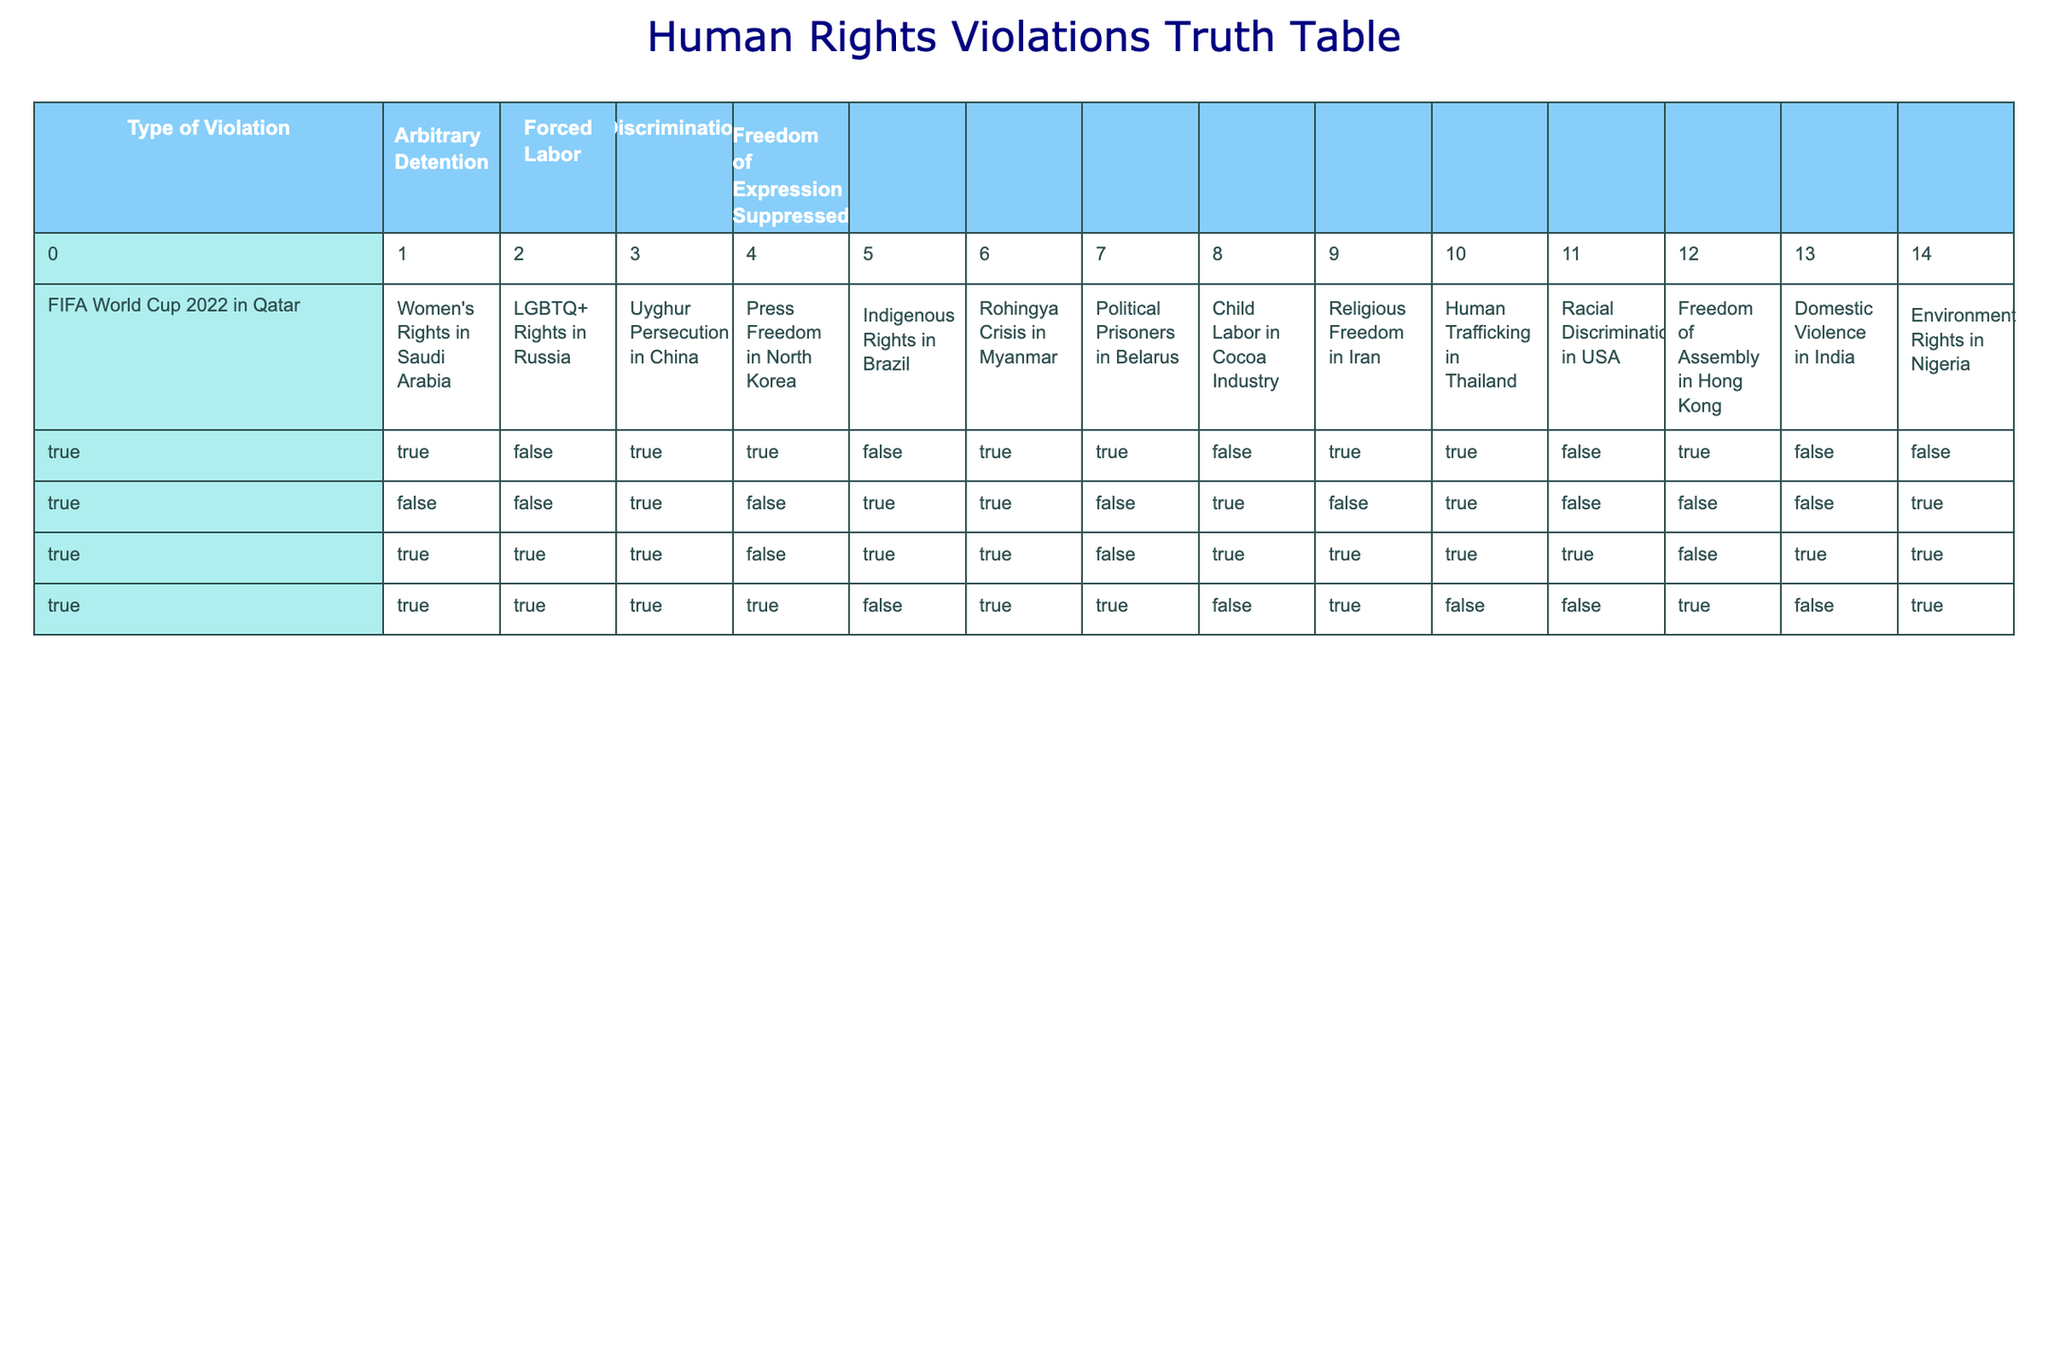What types of human rights violations are associated with the FIFA World Cup 2022 in Qatar? The table shows that the FIFA World Cup 2022 in Qatar is associated with Arbitrary Detention, Forced Labor, Discrimination, and Freedom of Expression Suppressed, as all these categories have the value TRUE.
Answer: Arbitrary Detention, Forced Labor, Discrimination, Freedom of Expression Suppressed Which situation has the least number of human rights violations? By examining the table, the situation with the least number of TRUE values is "Indigenous Rights in Brazil," as it only has two true violations (Forced Labor and Discrimination).
Answer: Indigenous Rights in Brazil Is there any situation that reports all types of human rights violations? Looking through the data, the "FIFA World Cup 2022 in Qatar" and "Uyghur Persecution in China" both show TRUE for all types of violations. Therefore, both situations report all types of violations.
Answer: Yes, two situations What percentage of the situations listed involve Forced Labor? There are 14 situations listed in total. Counting the occurrences of TRUE for Forced Labor, we find 7 situations (FIFA World Cup 2022 in Qatar, Uyghur Persecution in China, Indigenous Rights in Brazil, Human Trafficking in Thailand, Women's Rights in Saudi Arabia, Rohingya Crisis in Myanmar, and Child Labor in Cocoa Industry). To find the percentage, (7/14) * 100 = 50%.
Answer: 50% How many situations report that Freedom of Expression is suppressed? By inspecting the column for Freedom of Expression Suppressed, we find TRUE in 8 situations: FIFA World Cup 2022 in Qatar, Women's Rights in Saudi Arabia, LGBTQ+ Rights in Russia, Uyghur Persecution in China, Press Freedom in North Korea, Political Prisoners in Belarus, Religious Freedom in Iran, and Freedom of Assembly in Hong Kong.
Answer: 8 Are there more situations with Arbitrary Detention or with Domestic Violence? There are 10 situations with Arbitrary Detention (TRUE), and there are only 2 situations that indicate Domestic Violence in India (FALSE). The total shows that there are significantly more situations with Arbitrary Detention than with Domestic Violence.
Answer: More situations with Arbitrary Detention What common types of violations exist between the situations of Human Trafficking in Thailand and LGBTQ+ Rights in Russia? Both situations have only the Discrimination type marked TRUE, while all others (Arbitrary Detention, Forced Labor, Freedom of Expression Suppressed) are FALSE for LGBTQ+ Rights in Russia. This means that Discrimination is the common violation between these two situations.
Answer: Discrimination Which type of violation has the highest occurrence across all situations? Analyzing the presence of each type of violation, we find that Forced Labor occurs in 8 situations, making it the highest occurrence among all types.
Answer: Forced Labor 